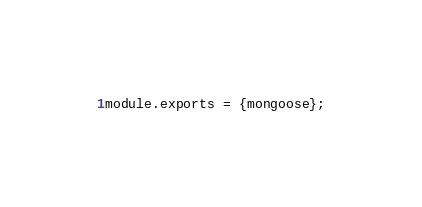<code> <loc_0><loc_0><loc_500><loc_500><_JavaScript_>module.exports = {mongoose};


</code> 